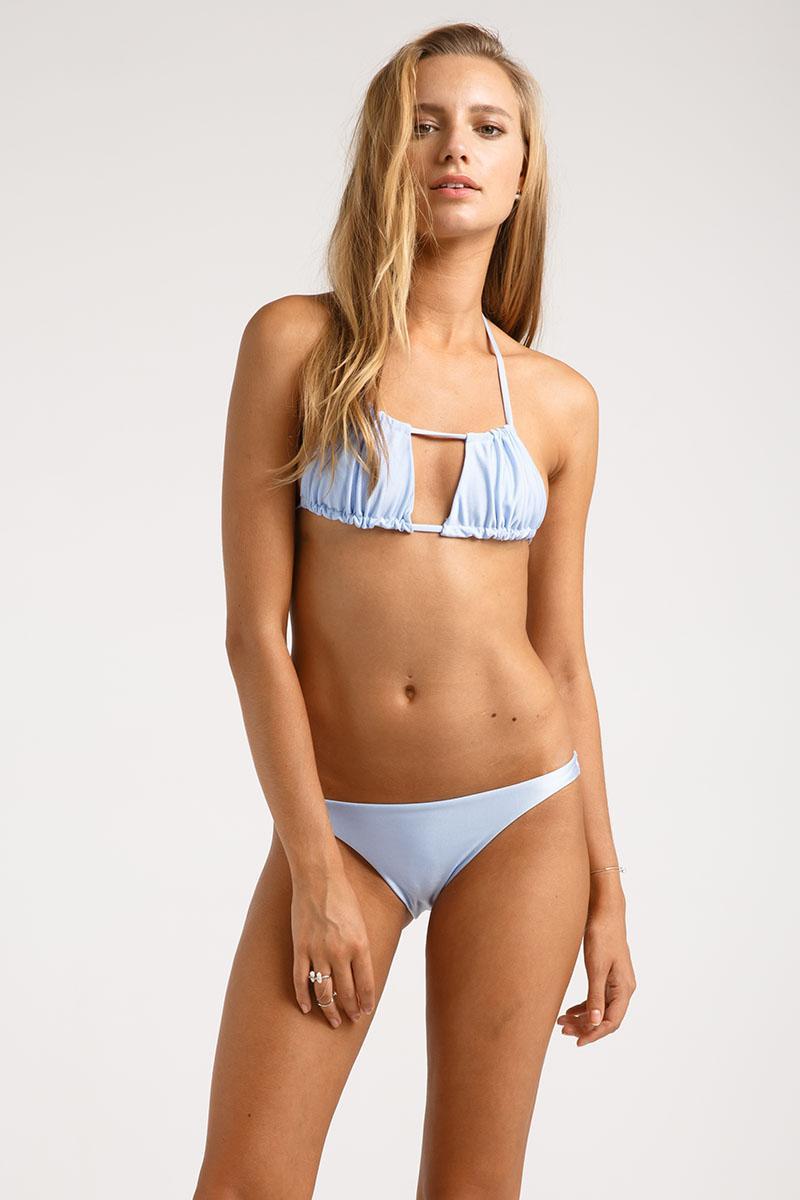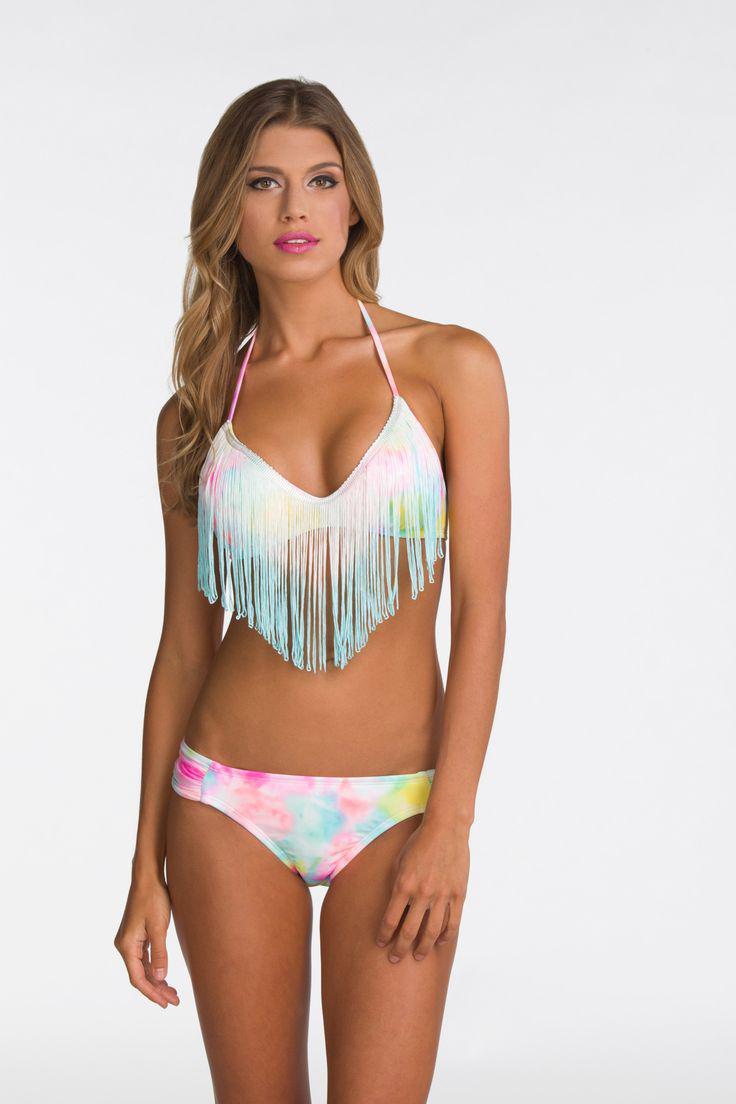The first image is the image on the left, the second image is the image on the right. For the images shown, is this caption "There is one green bikini" true? Answer yes or no. No. The first image is the image on the left, the second image is the image on the right. Given the left and right images, does the statement "A blonde model wears a light green bikini in one image." hold true? Answer yes or no. No. 